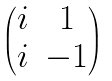Convert formula to latex. <formula><loc_0><loc_0><loc_500><loc_500>\begin{pmatrix} i & 1 \\ i & - 1 \end{pmatrix}</formula> 